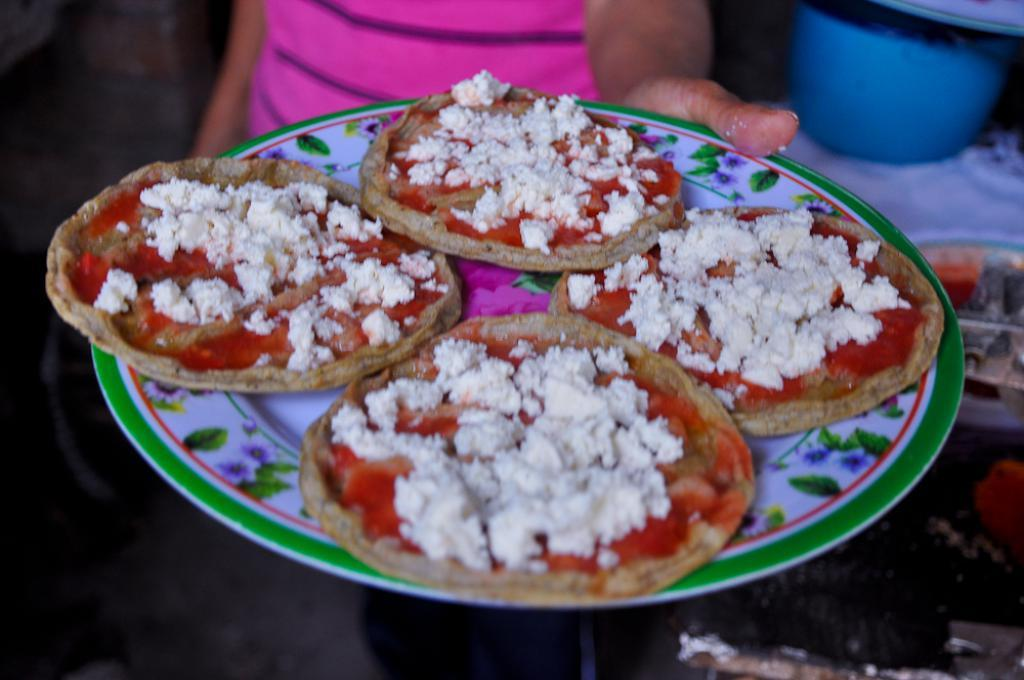What can be seen in the image? There is a person in the image. Can you describe the person's appearance? The person's face is not visible. What is the person holding in the image? The person is holding a plate. What is on the plate? The plate contains food. What else is visible in the image? There is an object in the top right of the image. What type of trail can be seen in the image? There is no trail present in the image. Is there a volcano visible in the image? No, there is no volcano in the image. 